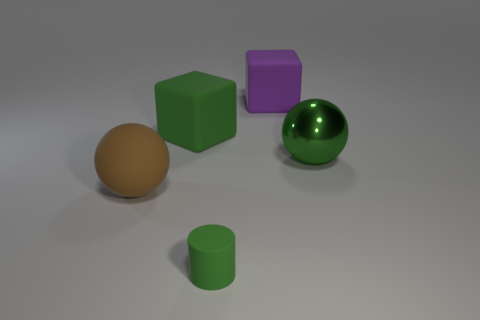Subtract all cyan blocks. Subtract all blue balls. How many blocks are left? 2 Subtract all green spheres. How many blue cubes are left? 0 Add 3 big objects. How many purples exist? 0 Subtract all tiny green things. Subtract all green cubes. How many objects are left? 3 Add 1 rubber balls. How many rubber balls are left? 2 Add 4 purple rubber cylinders. How many purple rubber cylinders exist? 4 Add 5 cubes. How many objects exist? 10 Subtract all brown balls. How many balls are left? 1 Subtract 0 brown cubes. How many objects are left? 5 Subtract all cylinders. How many objects are left? 4 